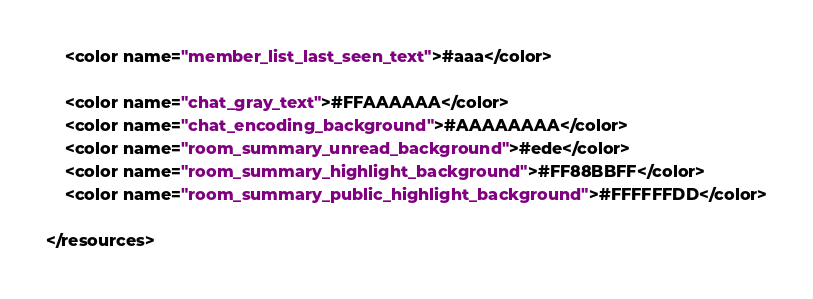<code> <loc_0><loc_0><loc_500><loc_500><_XML_>    <color name="member_list_last_seen_text">#aaa</color>

    <color name="chat_gray_text">#FFAAAAAA</color>
    <color name="chat_encoding_background">#AAAAAAAA</color>
    <color name="room_summary_unread_background">#ede</color>
    <color name="room_summary_highlight_background">#FF88BBFF</color>
    <color name="room_summary_public_highlight_background">#FFFFFFDD</color>

</resources></code> 